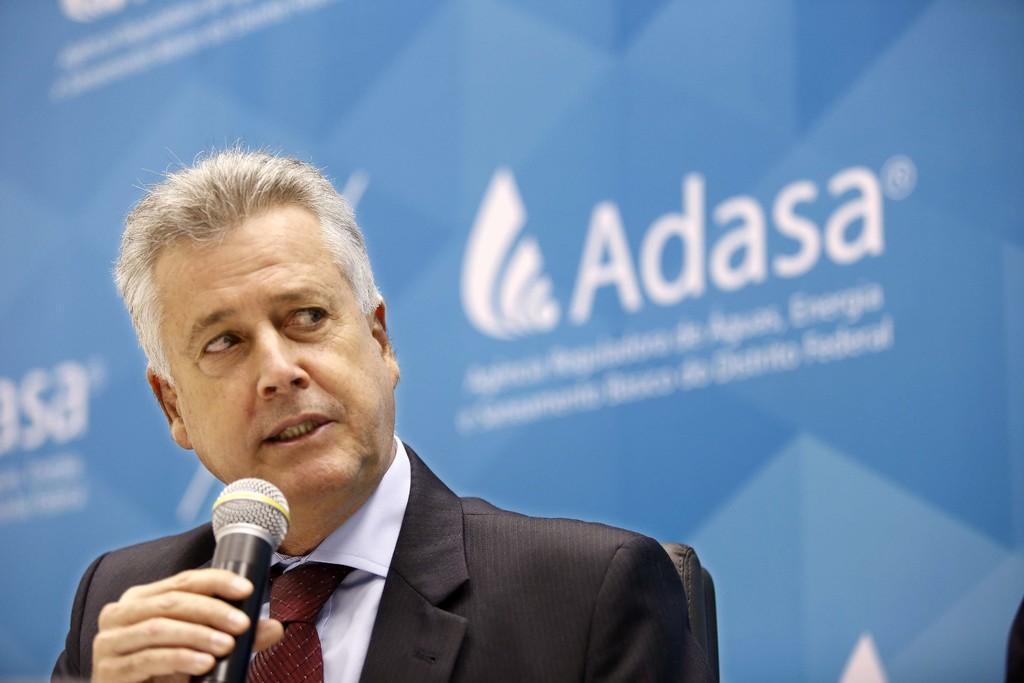In one or two sentences, can you explain what this image depicts? In the picture we can find a man talking into microphone. The man is wearing a blazer, tie and shirt background we can find some hoarding and advertisements. 